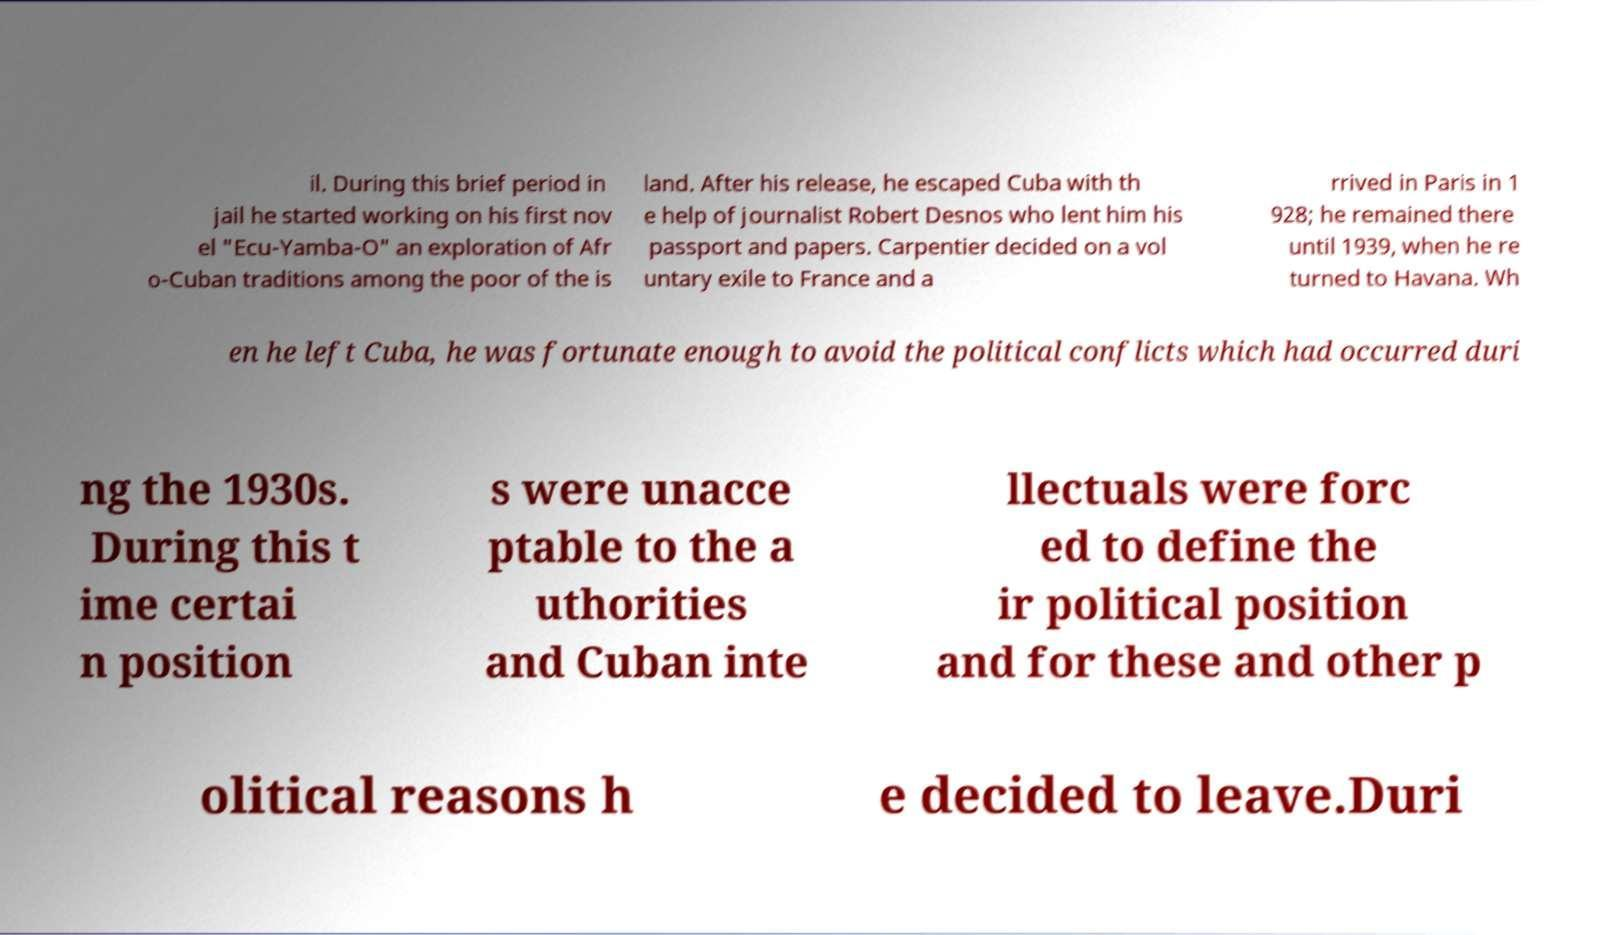Could you assist in decoding the text presented in this image and type it out clearly? il. During this brief period in jail he started working on his first nov el "Ecu-Yamba-O" an exploration of Afr o-Cuban traditions among the poor of the is land. After his release, he escaped Cuba with th e help of journalist Robert Desnos who lent him his passport and papers. Carpentier decided on a vol untary exile to France and a rrived in Paris in 1 928; he remained there until 1939, when he re turned to Havana. Wh en he left Cuba, he was fortunate enough to avoid the political conflicts which had occurred duri ng the 1930s. During this t ime certai n position s were unacce ptable to the a uthorities and Cuban inte llectuals were forc ed to define the ir political position and for these and other p olitical reasons h e decided to leave.Duri 